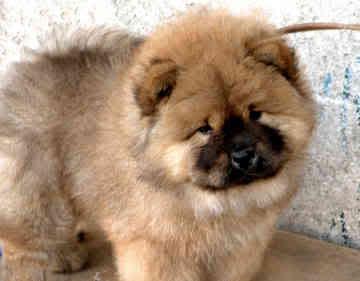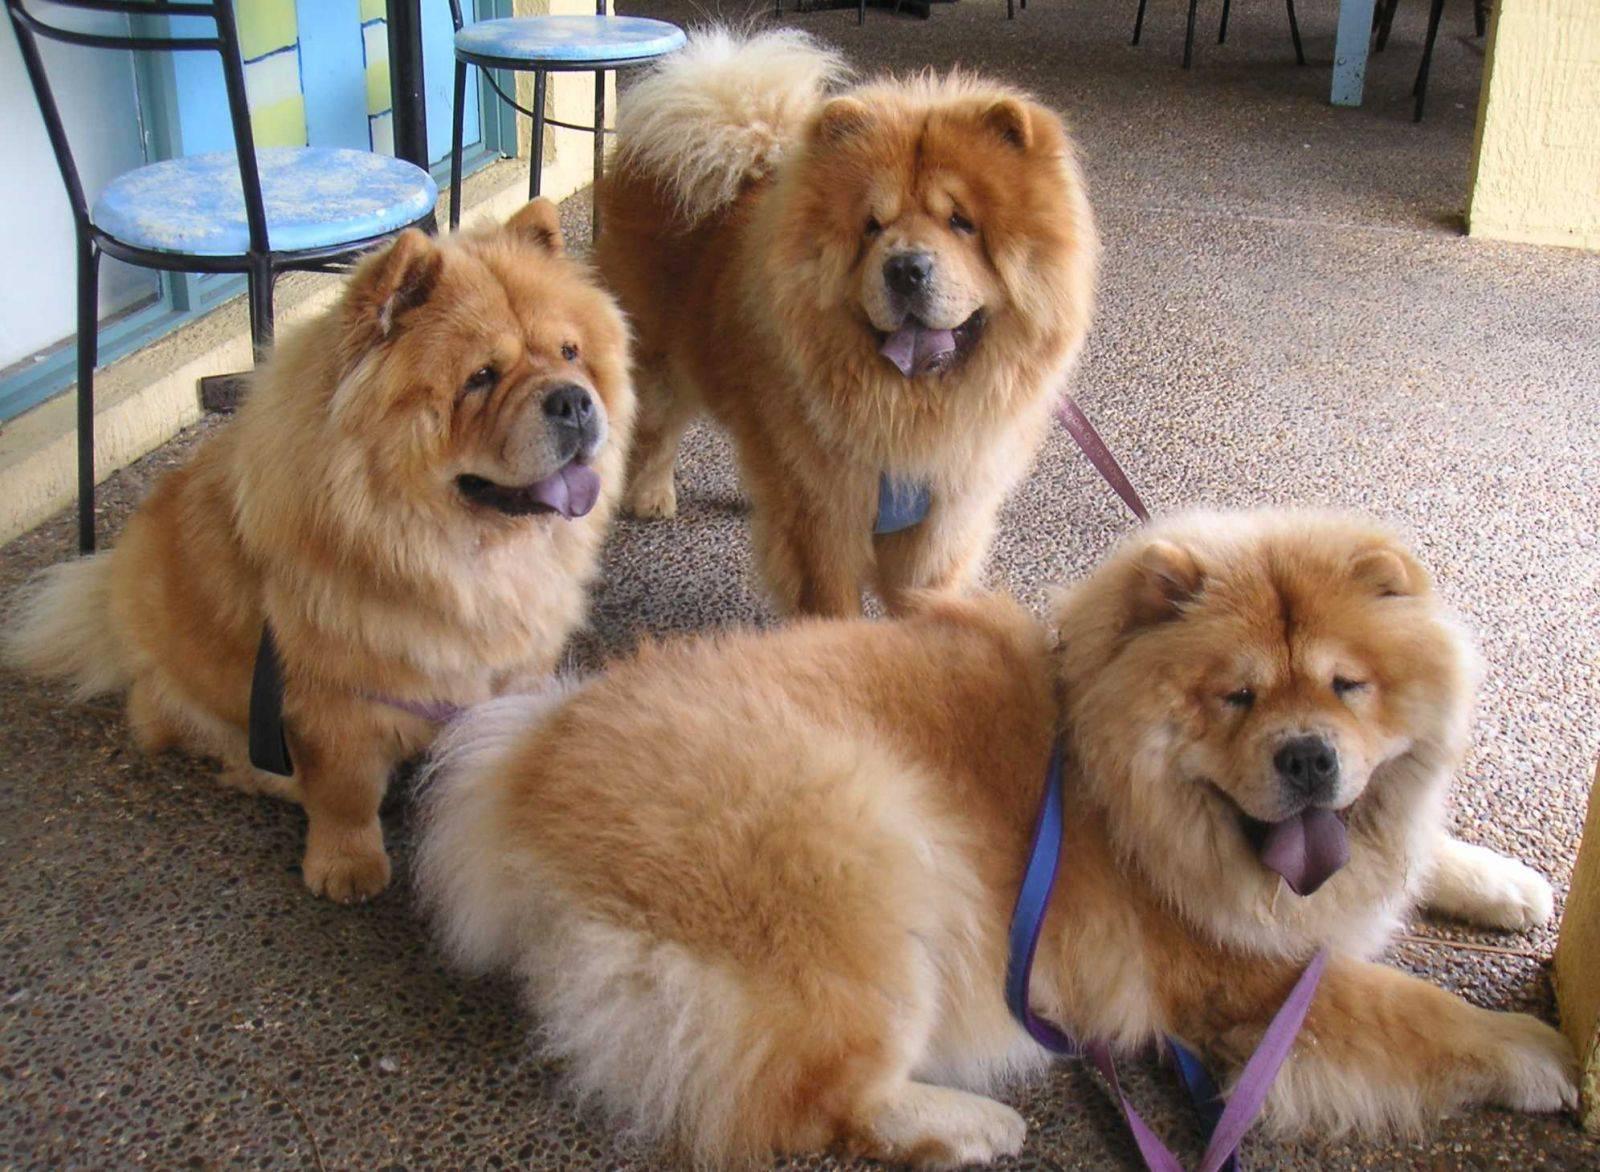The first image is the image on the left, the second image is the image on the right. Evaluate the accuracy of this statement regarding the images: "One of the images shows at least two dogs.". Is it true? Answer yes or no. Yes. The first image is the image on the left, the second image is the image on the right. Analyze the images presented: Is the assertion "There are two dogs" valid? Answer yes or no. No. 